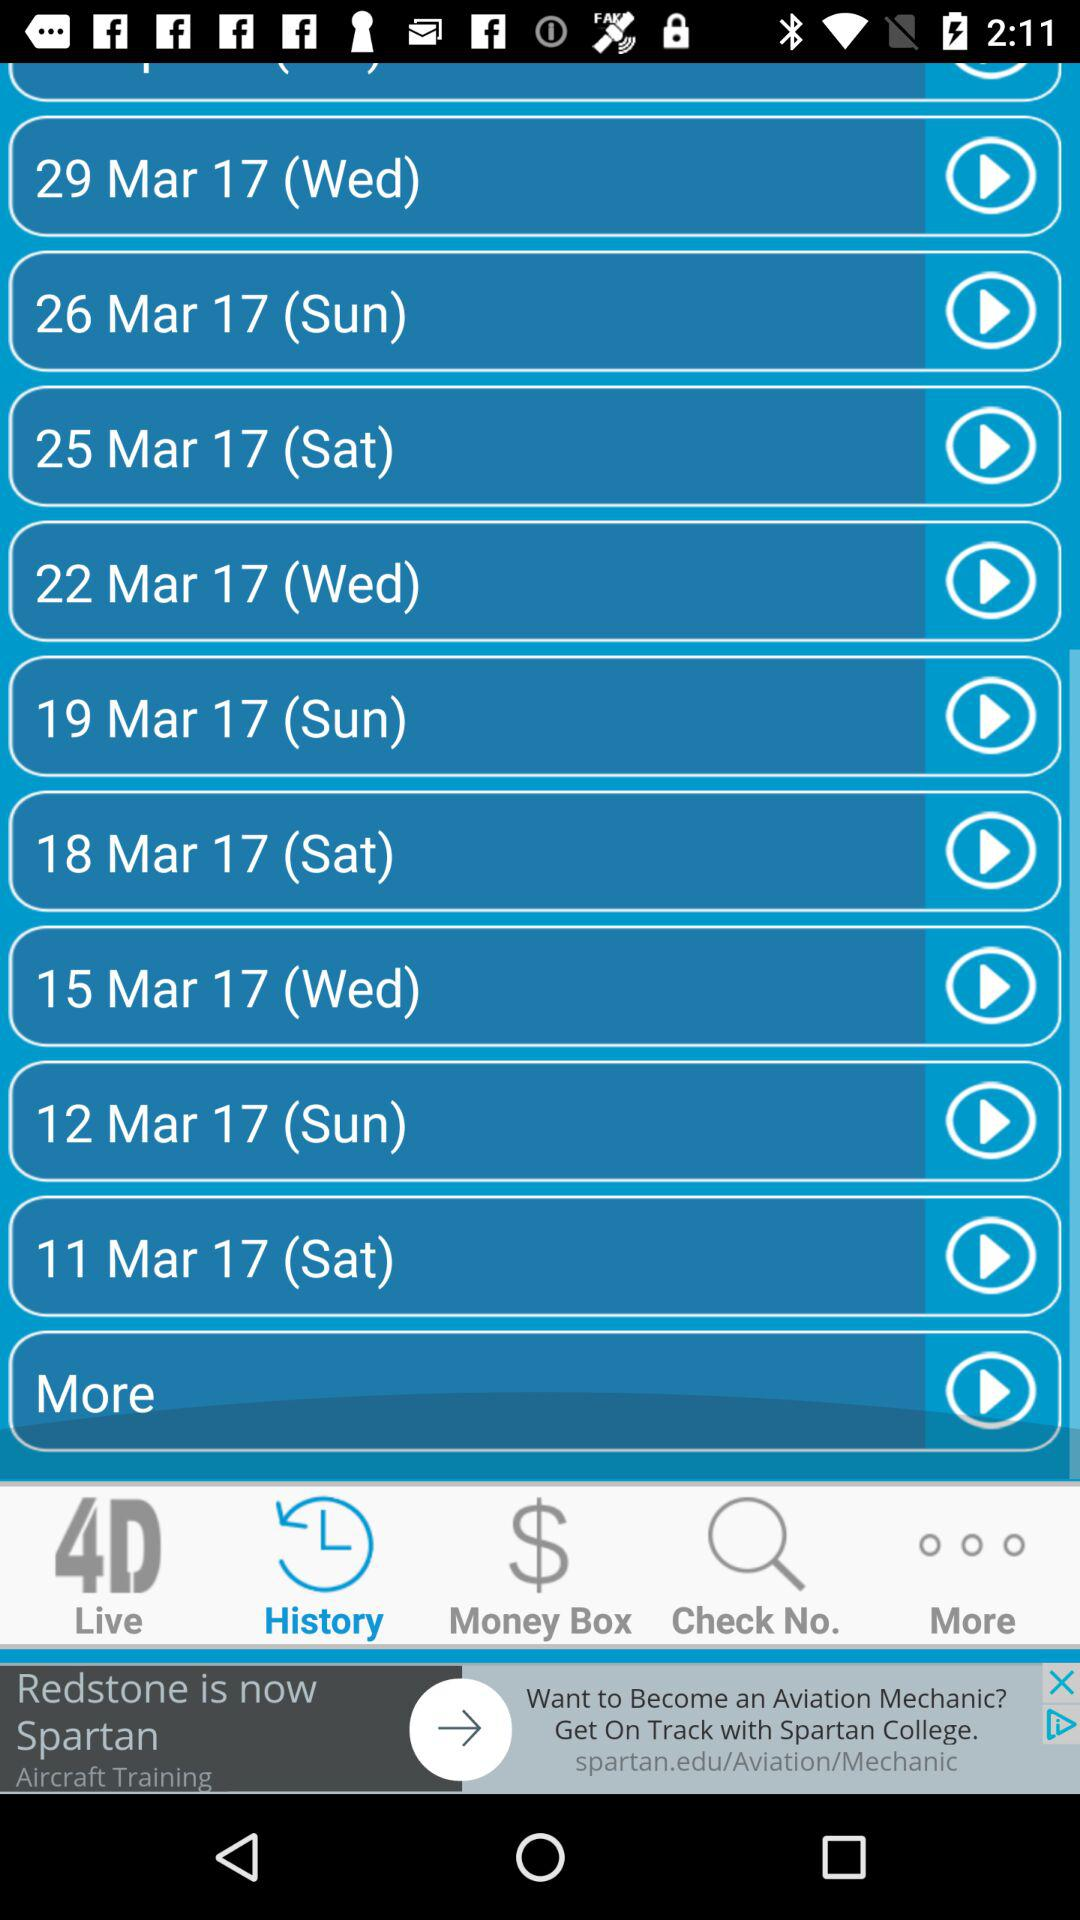Which day is 15 March 2017 The day is Wednesday. 